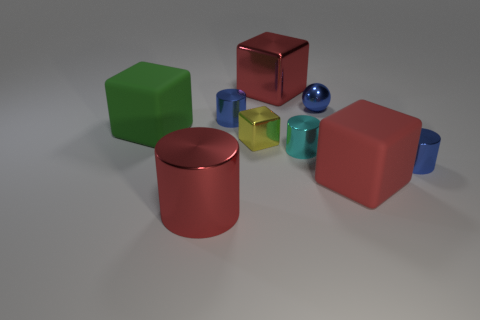Can you tell me about the colors of the blocks in the image? Certainly! The image showcases blocks of various colors: there's a vibrant green cube, a glossy red cube, and a matte blue cube, along with smaller transparent and yellow cubes. 